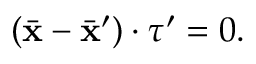<formula> <loc_0><loc_0><loc_500><loc_500>( \ B a r { x } - \ B a r { x } ^ { \prime } ) \cdot \boldsymbol \tau ^ { \prime } = 0 .</formula> 